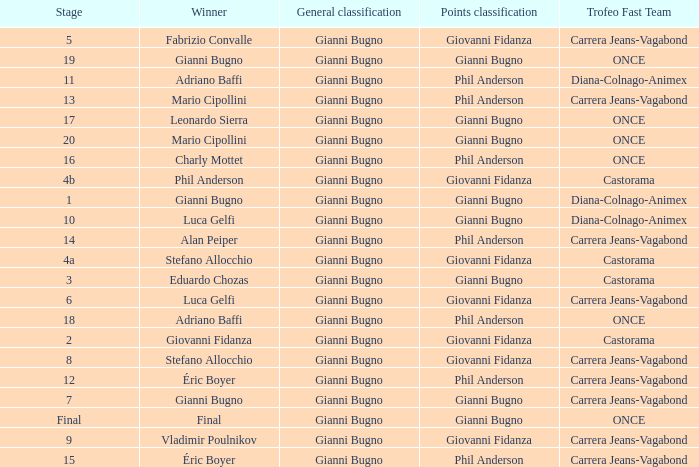Who is the trofeo fast team in stage 10? Diana-Colnago-Animex. 